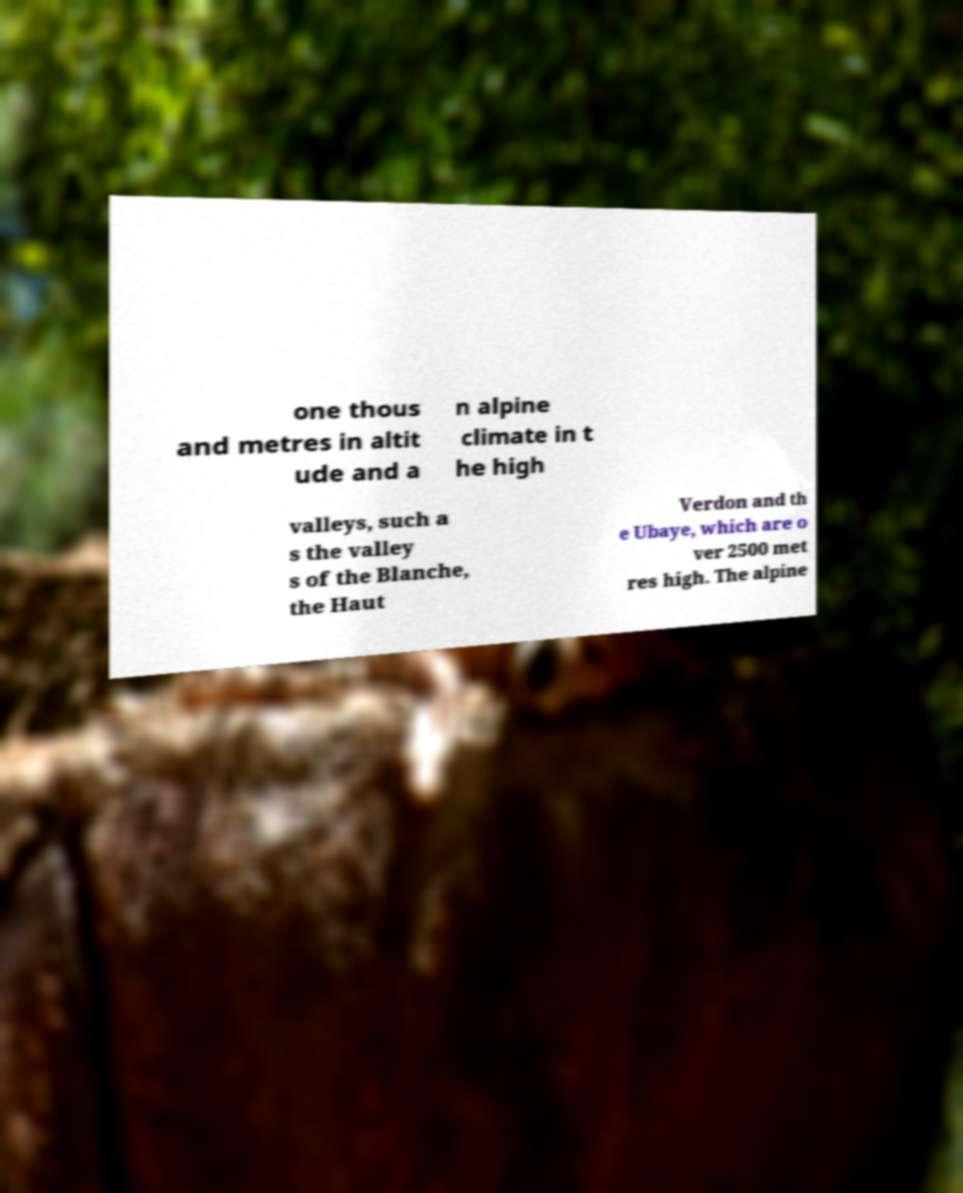Please read and relay the text visible in this image. What does it say? one thous and metres in altit ude and a n alpine climate in t he high valleys, such a s the valley s of the Blanche, the Haut Verdon and th e Ubaye, which are o ver 2500 met res high. The alpine 